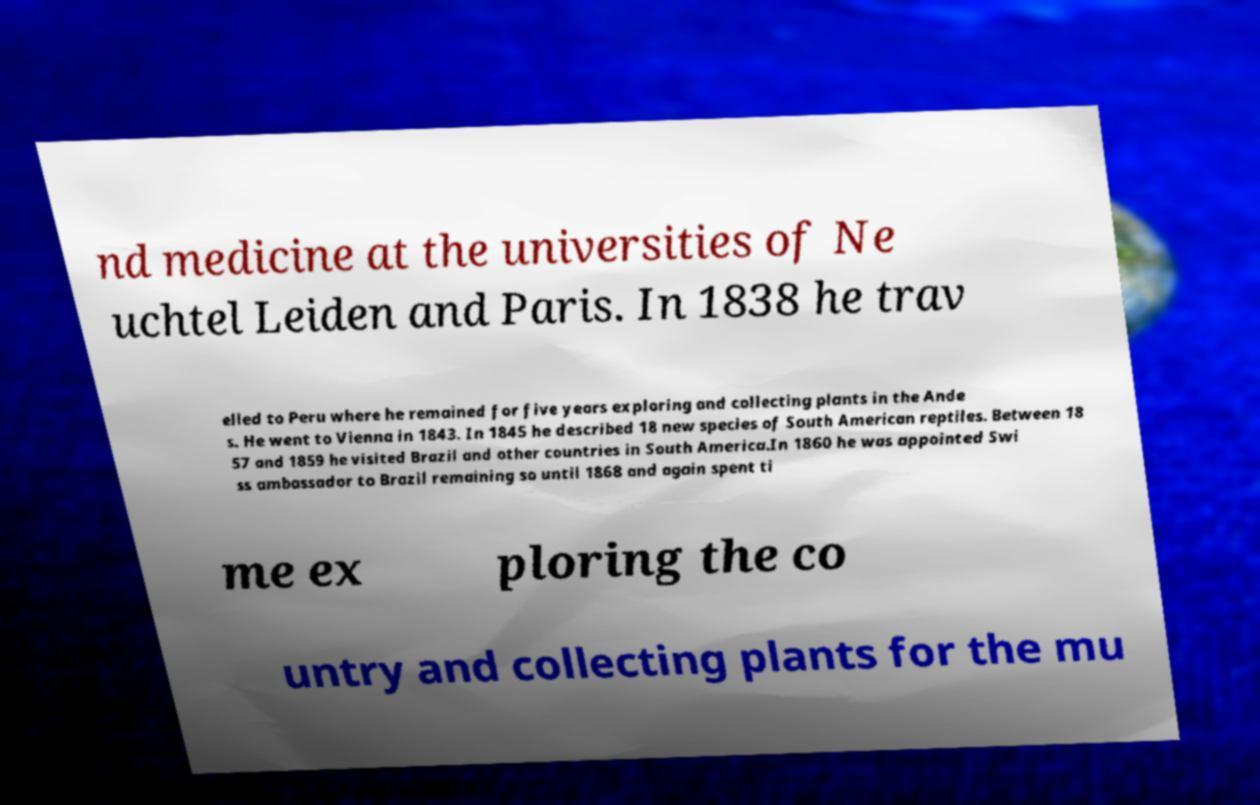Please read and relay the text visible in this image. What does it say? nd medicine at the universities of Ne uchtel Leiden and Paris. In 1838 he trav elled to Peru where he remained for five years exploring and collecting plants in the Ande s. He went to Vienna in 1843. In 1845 he described 18 new species of South American reptiles. Between 18 57 and 1859 he visited Brazil and other countries in South America.In 1860 he was appointed Swi ss ambassador to Brazil remaining so until 1868 and again spent ti me ex ploring the co untry and collecting plants for the mu 